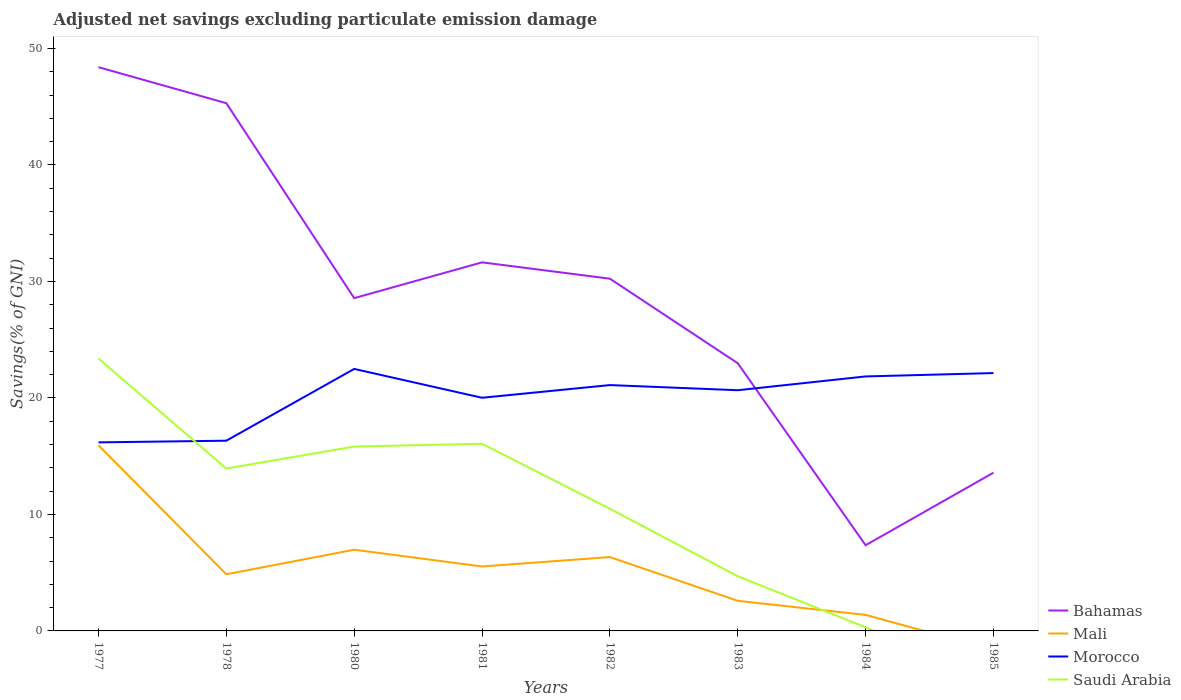How many different coloured lines are there?
Offer a terse response. 4. Across all years, what is the maximum adjusted net savings in Mali?
Ensure brevity in your answer.  0. What is the total adjusted net savings in Bahamas in the graph?
Offer a very short reply. 3.09. What is the difference between the highest and the second highest adjusted net savings in Mali?
Give a very brief answer. 15.94. Are the values on the major ticks of Y-axis written in scientific E-notation?
Your answer should be compact. No. Where does the legend appear in the graph?
Make the answer very short. Bottom right. How are the legend labels stacked?
Your answer should be very brief. Vertical. What is the title of the graph?
Offer a terse response. Adjusted net savings excluding particulate emission damage. Does "Latin America(developing only)" appear as one of the legend labels in the graph?
Give a very brief answer. No. What is the label or title of the Y-axis?
Ensure brevity in your answer.  Savings(% of GNI). What is the Savings(% of GNI) of Bahamas in 1977?
Provide a succinct answer. 48.4. What is the Savings(% of GNI) of Mali in 1977?
Give a very brief answer. 15.94. What is the Savings(% of GNI) of Morocco in 1977?
Ensure brevity in your answer.  16.19. What is the Savings(% of GNI) of Saudi Arabia in 1977?
Your response must be concise. 23.38. What is the Savings(% of GNI) in Bahamas in 1978?
Offer a very short reply. 45.31. What is the Savings(% of GNI) in Mali in 1978?
Make the answer very short. 4.86. What is the Savings(% of GNI) in Morocco in 1978?
Your answer should be very brief. 16.33. What is the Savings(% of GNI) in Saudi Arabia in 1978?
Provide a succinct answer. 13.94. What is the Savings(% of GNI) of Bahamas in 1980?
Offer a terse response. 28.57. What is the Savings(% of GNI) in Mali in 1980?
Offer a very short reply. 6.97. What is the Savings(% of GNI) in Morocco in 1980?
Keep it short and to the point. 22.49. What is the Savings(% of GNI) in Saudi Arabia in 1980?
Offer a terse response. 15.83. What is the Savings(% of GNI) of Bahamas in 1981?
Your answer should be compact. 31.64. What is the Savings(% of GNI) of Mali in 1981?
Keep it short and to the point. 5.53. What is the Savings(% of GNI) in Morocco in 1981?
Your answer should be compact. 20.02. What is the Savings(% of GNI) of Saudi Arabia in 1981?
Offer a very short reply. 16.07. What is the Savings(% of GNI) of Bahamas in 1982?
Offer a terse response. 30.24. What is the Savings(% of GNI) of Mali in 1982?
Give a very brief answer. 6.34. What is the Savings(% of GNI) in Morocco in 1982?
Your answer should be compact. 21.1. What is the Savings(% of GNI) in Saudi Arabia in 1982?
Provide a short and direct response. 10.49. What is the Savings(% of GNI) of Bahamas in 1983?
Provide a succinct answer. 22.98. What is the Savings(% of GNI) of Mali in 1983?
Your answer should be compact. 2.58. What is the Savings(% of GNI) in Morocco in 1983?
Keep it short and to the point. 20.66. What is the Savings(% of GNI) in Saudi Arabia in 1983?
Make the answer very short. 4.69. What is the Savings(% of GNI) of Bahamas in 1984?
Your answer should be compact. 7.36. What is the Savings(% of GNI) in Mali in 1984?
Give a very brief answer. 1.38. What is the Savings(% of GNI) of Morocco in 1984?
Ensure brevity in your answer.  21.85. What is the Savings(% of GNI) of Saudi Arabia in 1984?
Your response must be concise. 0.31. What is the Savings(% of GNI) of Bahamas in 1985?
Offer a terse response. 13.58. What is the Savings(% of GNI) of Morocco in 1985?
Give a very brief answer. 22.14. What is the Savings(% of GNI) of Saudi Arabia in 1985?
Offer a terse response. 0. Across all years, what is the maximum Savings(% of GNI) in Bahamas?
Keep it short and to the point. 48.4. Across all years, what is the maximum Savings(% of GNI) of Mali?
Give a very brief answer. 15.94. Across all years, what is the maximum Savings(% of GNI) in Morocco?
Keep it short and to the point. 22.49. Across all years, what is the maximum Savings(% of GNI) of Saudi Arabia?
Give a very brief answer. 23.38. Across all years, what is the minimum Savings(% of GNI) of Bahamas?
Provide a succinct answer. 7.36. Across all years, what is the minimum Savings(% of GNI) in Morocco?
Provide a short and direct response. 16.19. Across all years, what is the minimum Savings(% of GNI) of Saudi Arabia?
Ensure brevity in your answer.  0. What is the total Savings(% of GNI) in Bahamas in the graph?
Your answer should be very brief. 228.07. What is the total Savings(% of GNI) of Mali in the graph?
Make the answer very short. 43.61. What is the total Savings(% of GNI) of Morocco in the graph?
Your answer should be compact. 160.78. What is the total Savings(% of GNI) of Saudi Arabia in the graph?
Provide a succinct answer. 84.71. What is the difference between the Savings(% of GNI) in Bahamas in 1977 and that in 1978?
Your answer should be compact. 3.09. What is the difference between the Savings(% of GNI) in Mali in 1977 and that in 1978?
Keep it short and to the point. 11.07. What is the difference between the Savings(% of GNI) in Morocco in 1977 and that in 1978?
Offer a terse response. -0.14. What is the difference between the Savings(% of GNI) of Saudi Arabia in 1977 and that in 1978?
Your response must be concise. 9.44. What is the difference between the Savings(% of GNI) in Bahamas in 1977 and that in 1980?
Keep it short and to the point. 19.83. What is the difference between the Savings(% of GNI) in Mali in 1977 and that in 1980?
Your answer should be compact. 8.96. What is the difference between the Savings(% of GNI) in Morocco in 1977 and that in 1980?
Your answer should be compact. -6.3. What is the difference between the Savings(% of GNI) in Saudi Arabia in 1977 and that in 1980?
Give a very brief answer. 7.56. What is the difference between the Savings(% of GNI) of Bahamas in 1977 and that in 1981?
Your answer should be compact. 16.75. What is the difference between the Savings(% of GNI) in Mali in 1977 and that in 1981?
Your response must be concise. 10.41. What is the difference between the Savings(% of GNI) in Morocco in 1977 and that in 1981?
Give a very brief answer. -3.83. What is the difference between the Savings(% of GNI) of Saudi Arabia in 1977 and that in 1981?
Offer a terse response. 7.32. What is the difference between the Savings(% of GNI) in Bahamas in 1977 and that in 1982?
Offer a terse response. 18.16. What is the difference between the Savings(% of GNI) in Mali in 1977 and that in 1982?
Offer a very short reply. 9.6. What is the difference between the Savings(% of GNI) of Morocco in 1977 and that in 1982?
Give a very brief answer. -4.92. What is the difference between the Savings(% of GNI) in Saudi Arabia in 1977 and that in 1982?
Make the answer very short. 12.9. What is the difference between the Savings(% of GNI) in Bahamas in 1977 and that in 1983?
Offer a terse response. 25.42. What is the difference between the Savings(% of GNI) in Mali in 1977 and that in 1983?
Provide a short and direct response. 13.35. What is the difference between the Savings(% of GNI) in Morocco in 1977 and that in 1983?
Keep it short and to the point. -4.48. What is the difference between the Savings(% of GNI) in Saudi Arabia in 1977 and that in 1983?
Make the answer very short. 18.69. What is the difference between the Savings(% of GNI) of Bahamas in 1977 and that in 1984?
Keep it short and to the point. 41.04. What is the difference between the Savings(% of GNI) in Mali in 1977 and that in 1984?
Make the answer very short. 14.56. What is the difference between the Savings(% of GNI) in Morocco in 1977 and that in 1984?
Ensure brevity in your answer.  -5.66. What is the difference between the Savings(% of GNI) of Saudi Arabia in 1977 and that in 1984?
Offer a terse response. 23.08. What is the difference between the Savings(% of GNI) of Bahamas in 1977 and that in 1985?
Offer a very short reply. 34.81. What is the difference between the Savings(% of GNI) in Morocco in 1977 and that in 1985?
Give a very brief answer. -5.95. What is the difference between the Savings(% of GNI) in Bahamas in 1978 and that in 1980?
Give a very brief answer. 16.74. What is the difference between the Savings(% of GNI) of Mali in 1978 and that in 1980?
Your response must be concise. -2.11. What is the difference between the Savings(% of GNI) in Morocco in 1978 and that in 1980?
Offer a terse response. -6.16. What is the difference between the Savings(% of GNI) in Saudi Arabia in 1978 and that in 1980?
Offer a terse response. -1.89. What is the difference between the Savings(% of GNI) in Bahamas in 1978 and that in 1981?
Provide a short and direct response. 13.66. What is the difference between the Savings(% of GNI) of Mali in 1978 and that in 1981?
Your answer should be compact. -0.67. What is the difference between the Savings(% of GNI) in Morocco in 1978 and that in 1981?
Your answer should be compact. -3.69. What is the difference between the Savings(% of GNI) of Saudi Arabia in 1978 and that in 1981?
Make the answer very short. -2.13. What is the difference between the Savings(% of GNI) in Bahamas in 1978 and that in 1982?
Provide a short and direct response. 15.07. What is the difference between the Savings(% of GNI) in Mali in 1978 and that in 1982?
Give a very brief answer. -1.48. What is the difference between the Savings(% of GNI) in Morocco in 1978 and that in 1982?
Provide a succinct answer. -4.77. What is the difference between the Savings(% of GNI) of Saudi Arabia in 1978 and that in 1982?
Your response must be concise. 3.45. What is the difference between the Savings(% of GNI) of Bahamas in 1978 and that in 1983?
Provide a succinct answer. 22.33. What is the difference between the Savings(% of GNI) of Mali in 1978 and that in 1983?
Your response must be concise. 2.28. What is the difference between the Savings(% of GNI) of Morocco in 1978 and that in 1983?
Keep it short and to the point. -4.33. What is the difference between the Savings(% of GNI) of Saudi Arabia in 1978 and that in 1983?
Keep it short and to the point. 9.25. What is the difference between the Savings(% of GNI) of Bahamas in 1978 and that in 1984?
Your answer should be compact. 37.95. What is the difference between the Savings(% of GNI) in Mali in 1978 and that in 1984?
Provide a short and direct response. 3.48. What is the difference between the Savings(% of GNI) in Morocco in 1978 and that in 1984?
Your response must be concise. -5.52. What is the difference between the Savings(% of GNI) of Saudi Arabia in 1978 and that in 1984?
Your response must be concise. 13.63. What is the difference between the Savings(% of GNI) of Bahamas in 1978 and that in 1985?
Provide a short and direct response. 31.72. What is the difference between the Savings(% of GNI) of Morocco in 1978 and that in 1985?
Offer a terse response. -5.81. What is the difference between the Savings(% of GNI) of Bahamas in 1980 and that in 1981?
Provide a succinct answer. -3.07. What is the difference between the Savings(% of GNI) in Mali in 1980 and that in 1981?
Your answer should be compact. 1.44. What is the difference between the Savings(% of GNI) of Morocco in 1980 and that in 1981?
Make the answer very short. 2.48. What is the difference between the Savings(% of GNI) in Saudi Arabia in 1980 and that in 1981?
Your response must be concise. -0.24. What is the difference between the Savings(% of GNI) of Bahamas in 1980 and that in 1982?
Ensure brevity in your answer.  -1.67. What is the difference between the Savings(% of GNI) in Mali in 1980 and that in 1982?
Give a very brief answer. 0.63. What is the difference between the Savings(% of GNI) of Morocco in 1980 and that in 1982?
Your answer should be compact. 1.39. What is the difference between the Savings(% of GNI) in Saudi Arabia in 1980 and that in 1982?
Provide a succinct answer. 5.34. What is the difference between the Savings(% of GNI) in Bahamas in 1980 and that in 1983?
Provide a short and direct response. 5.59. What is the difference between the Savings(% of GNI) of Mali in 1980 and that in 1983?
Provide a succinct answer. 4.39. What is the difference between the Savings(% of GNI) in Morocco in 1980 and that in 1983?
Offer a very short reply. 1.83. What is the difference between the Savings(% of GNI) of Saudi Arabia in 1980 and that in 1983?
Your response must be concise. 11.14. What is the difference between the Savings(% of GNI) in Bahamas in 1980 and that in 1984?
Ensure brevity in your answer.  21.21. What is the difference between the Savings(% of GNI) of Mali in 1980 and that in 1984?
Keep it short and to the point. 5.59. What is the difference between the Savings(% of GNI) in Morocco in 1980 and that in 1984?
Ensure brevity in your answer.  0.65. What is the difference between the Savings(% of GNI) in Saudi Arabia in 1980 and that in 1984?
Offer a terse response. 15.52. What is the difference between the Savings(% of GNI) of Bahamas in 1980 and that in 1985?
Make the answer very short. 14.99. What is the difference between the Savings(% of GNI) in Morocco in 1980 and that in 1985?
Provide a succinct answer. 0.36. What is the difference between the Savings(% of GNI) of Bahamas in 1981 and that in 1982?
Provide a short and direct response. 1.4. What is the difference between the Savings(% of GNI) of Mali in 1981 and that in 1982?
Make the answer very short. -0.81. What is the difference between the Savings(% of GNI) of Morocco in 1981 and that in 1982?
Your answer should be very brief. -1.09. What is the difference between the Savings(% of GNI) of Saudi Arabia in 1981 and that in 1982?
Make the answer very short. 5.58. What is the difference between the Savings(% of GNI) of Bahamas in 1981 and that in 1983?
Keep it short and to the point. 8.66. What is the difference between the Savings(% of GNI) in Mali in 1981 and that in 1983?
Your answer should be very brief. 2.95. What is the difference between the Savings(% of GNI) in Morocco in 1981 and that in 1983?
Give a very brief answer. -0.65. What is the difference between the Savings(% of GNI) in Saudi Arabia in 1981 and that in 1983?
Provide a short and direct response. 11.38. What is the difference between the Savings(% of GNI) in Bahamas in 1981 and that in 1984?
Your answer should be very brief. 24.28. What is the difference between the Savings(% of GNI) in Mali in 1981 and that in 1984?
Your response must be concise. 4.15. What is the difference between the Savings(% of GNI) of Morocco in 1981 and that in 1984?
Keep it short and to the point. -1.83. What is the difference between the Savings(% of GNI) in Saudi Arabia in 1981 and that in 1984?
Make the answer very short. 15.76. What is the difference between the Savings(% of GNI) of Bahamas in 1981 and that in 1985?
Give a very brief answer. 18.06. What is the difference between the Savings(% of GNI) of Morocco in 1981 and that in 1985?
Make the answer very short. -2.12. What is the difference between the Savings(% of GNI) in Bahamas in 1982 and that in 1983?
Your answer should be compact. 7.26. What is the difference between the Savings(% of GNI) of Mali in 1982 and that in 1983?
Ensure brevity in your answer.  3.76. What is the difference between the Savings(% of GNI) of Morocco in 1982 and that in 1983?
Make the answer very short. 0.44. What is the difference between the Savings(% of GNI) in Saudi Arabia in 1982 and that in 1983?
Your answer should be compact. 5.8. What is the difference between the Savings(% of GNI) in Bahamas in 1982 and that in 1984?
Your answer should be very brief. 22.88. What is the difference between the Savings(% of GNI) in Mali in 1982 and that in 1984?
Make the answer very short. 4.96. What is the difference between the Savings(% of GNI) in Morocco in 1982 and that in 1984?
Provide a short and direct response. -0.74. What is the difference between the Savings(% of GNI) in Saudi Arabia in 1982 and that in 1984?
Provide a short and direct response. 10.18. What is the difference between the Savings(% of GNI) of Bahamas in 1982 and that in 1985?
Your answer should be very brief. 16.66. What is the difference between the Savings(% of GNI) in Morocco in 1982 and that in 1985?
Provide a succinct answer. -1.03. What is the difference between the Savings(% of GNI) of Bahamas in 1983 and that in 1984?
Give a very brief answer. 15.62. What is the difference between the Savings(% of GNI) of Mali in 1983 and that in 1984?
Your answer should be very brief. 1.21. What is the difference between the Savings(% of GNI) of Morocco in 1983 and that in 1984?
Make the answer very short. -1.18. What is the difference between the Savings(% of GNI) of Saudi Arabia in 1983 and that in 1984?
Make the answer very short. 4.38. What is the difference between the Savings(% of GNI) in Bahamas in 1983 and that in 1985?
Provide a succinct answer. 9.4. What is the difference between the Savings(% of GNI) of Morocco in 1983 and that in 1985?
Offer a very short reply. -1.47. What is the difference between the Savings(% of GNI) of Bahamas in 1984 and that in 1985?
Your answer should be compact. -6.23. What is the difference between the Savings(% of GNI) in Morocco in 1984 and that in 1985?
Your response must be concise. -0.29. What is the difference between the Savings(% of GNI) in Bahamas in 1977 and the Savings(% of GNI) in Mali in 1978?
Give a very brief answer. 43.53. What is the difference between the Savings(% of GNI) of Bahamas in 1977 and the Savings(% of GNI) of Morocco in 1978?
Your answer should be very brief. 32.07. What is the difference between the Savings(% of GNI) in Bahamas in 1977 and the Savings(% of GNI) in Saudi Arabia in 1978?
Make the answer very short. 34.46. What is the difference between the Savings(% of GNI) in Mali in 1977 and the Savings(% of GNI) in Morocco in 1978?
Make the answer very short. -0.39. What is the difference between the Savings(% of GNI) of Mali in 1977 and the Savings(% of GNI) of Saudi Arabia in 1978?
Offer a very short reply. 2. What is the difference between the Savings(% of GNI) of Morocco in 1977 and the Savings(% of GNI) of Saudi Arabia in 1978?
Provide a short and direct response. 2.25. What is the difference between the Savings(% of GNI) in Bahamas in 1977 and the Savings(% of GNI) in Mali in 1980?
Provide a short and direct response. 41.42. What is the difference between the Savings(% of GNI) in Bahamas in 1977 and the Savings(% of GNI) in Morocco in 1980?
Ensure brevity in your answer.  25.9. What is the difference between the Savings(% of GNI) of Bahamas in 1977 and the Savings(% of GNI) of Saudi Arabia in 1980?
Give a very brief answer. 32.57. What is the difference between the Savings(% of GNI) of Mali in 1977 and the Savings(% of GNI) of Morocco in 1980?
Your answer should be very brief. -6.56. What is the difference between the Savings(% of GNI) in Mali in 1977 and the Savings(% of GNI) in Saudi Arabia in 1980?
Offer a terse response. 0.11. What is the difference between the Savings(% of GNI) in Morocco in 1977 and the Savings(% of GNI) in Saudi Arabia in 1980?
Provide a short and direct response. 0.36. What is the difference between the Savings(% of GNI) in Bahamas in 1977 and the Savings(% of GNI) in Mali in 1981?
Ensure brevity in your answer.  42.86. What is the difference between the Savings(% of GNI) in Bahamas in 1977 and the Savings(% of GNI) in Morocco in 1981?
Ensure brevity in your answer.  28.38. What is the difference between the Savings(% of GNI) in Bahamas in 1977 and the Savings(% of GNI) in Saudi Arabia in 1981?
Offer a very short reply. 32.33. What is the difference between the Savings(% of GNI) in Mali in 1977 and the Savings(% of GNI) in Morocco in 1981?
Offer a terse response. -4.08. What is the difference between the Savings(% of GNI) of Mali in 1977 and the Savings(% of GNI) of Saudi Arabia in 1981?
Make the answer very short. -0.13. What is the difference between the Savings(% of GNI) in Morocco in 1977 and the Savings(% of GNI) in Saudi Arabia in 1981?
Offer a terse response. 0.12. What is the difference between the Savings(% of GNI) of Bahamas in 1977 and the Savings(% of GNI) of Mali in 1982?
Your answer should be compact. 42.06. What is the difference between the Savings(% of GNI) in Bahamas in 1977 and the Savings(% of GNI) in Morocco in 1982?
Make the answer very short. 27.29. What is the difference between the Savings(% of GNI) in Bahamas in 1977 and the Savings(% of GNI) in Saudi Arabia in 1982?
Offer a terse response. 37.91. What is the difference between the Savings(% of GNI) in Mali in 1977 and the Savings(% of GNI) in Morocco in 1982?
Offer a very short reply. -5.17. What is the difference between the Savings(% of GNI) of Mali in 1977 and the Savings(% of GNI) of Saudi Arabia in 1982?
Your answer should be very brief. 5.45. What is the difference between the Savings(% of GNI) of Morocco in 1977 and the Savings(% of GNI) of Saudi Arabia in 1982?
Give a very brief answer. 5.7. What is the difference between the Savings(% of GNI) in Bahamas in 1977 and the Savings(% of GNI) in Mali in 1983?
Ensure brevity in your answer.  45.81. What is the difference between the Savings(% of GNI) of Bahamas in 1977 and the Savings(% of GNI) of Morocco in 1983?
Your response must be concise. 27.73. What is the difference between the Savings(% of GNI) in Bahamas in 1977 and the Savings(% of GNI) in Saudi Arabia in 1983?
Offer a terse response. 43.7. What is the difference between the Savings(% of GNI) in Mali in 1977 and the Savings(% of GNI) in Morocco in 1983?
Your answer should be compact. -4.73. What is the difference between the Savings(% of GNI) of Mali in 1977 and the Savings(% of GNI) of Saudi Arabia in 1983?
Your answer should be compact. 11.25. What is the difference between the Savings(% of GNI) of Morocco in 1977 and the Savings(% of GNI) of Saudi Arabia in 1983?
Offer a very short reply. 11.5. What is the difference between the Savings(% of GNI) in Bahamas in 1977 and the Savings(% of GNI) in Mali in 1984?
Provide a short and direct response. 47.02. What is the difference between the Savings(% of GNI) of Bahamas in 1977 and the Savings(% of GNI) of Morocco in 1984?
Your answer should be compact. 26.55. What is the difference between the Savings(% of GNI) in Bahamas in 1977 and the Savings(% of GNI) in Saudi Arabia in 1984?
Offer a terse response. 48.09. What is the difference between the Savings(% of GNI) in Mali in 1977 and the Savings(% of GNI) in Morocco in 1984?
Your answer should be very brief. -5.91. What is the difference between the Savings(% of GNI) of Mali in 1977 and the Savings(% of GNI) of Saudi Arabia in 1984?
Your answer should be very brief. 15.63. What is the difference between the Savings(% of GNI) of Morocco in 1977 and the Savings(% of GNI) of Saudi Arabia in 1984?
Your answer should be compact. 15.88. What is the difference between the Savings(% of GNI) of Bahamas in 1977 and the Savings(% of GNI) of Morocco in 1985?
Offer a very short reply. 26.26. What is the difference between the Savings(% of GNI) in Mali in 1977 and the Savings(% of GNI) in Morocco in 1985?
Ensure brevity in your answer.  -6.2. What is the difference between the Savings(% of GNI) of Bahamas in 1978 and the Savings(% of GNI) of Mali in 1980?
Keep it short and to the point. 38.33. What is the difference between the Savings(% of GNI) in Bahamas in 1978 and the Savings(% of GNI) in Morocco in 1980?
Provide a short and direct response. 22.81. What is the difference between the Savings(% of GNI) of Bahamas in 1978 and the Savings(% of GNI) of Saudi Arabia in 1980?
Offer a very short reply. 29.48. What is the difference between the Savings(% of GNI) in Mali in 1978 and the Savings(% of GNI) in Morocco in 1980?
Make the answer very short. -17.63. What is the difference between the Savings(% of GNI) in Mali in 1978 and the Savings(% of GNI) in Saudi Arabia in 1980?
Give a very brief answer. -10.97. What is the difference between the Savings(% of GNI) of Morocco in 1978 and the Savings(% of GNI) of Saudi Arabia in 1980?
Give a very brief answer. 0.5. What is the difference between the Savings(% of GNI) in Bahamas in 1978 and the Savings(% of GNI) in Mali in 1981?
Make the answer very short. 39.77. What is the difference between the Savings(% of GNI) in Bahamas in 1978 and the Savings(% of GNI) in Morocco in 1981?
Your answer should be compact. 25.29. What is the difference between the Savings(% of GNI) of Bahamas in 1978 and the Savings(% of GNI) of Saudi Arabia in 1981?
Keep it short and to the point. 29.24. What is the difference between the Savings(% of GNI) of Mali in 1978 and the Savings(% of GNI) of Morocco in 1981?
Ensure brevity in your answer.  -15.15. What is the difference between the Savings(% of GNI) in Mali in 1978 and the Savings(% of GNI) in Saudi Arabia in 1981?
Ensure brevity in your answer.  -11.21. What is the difference between the Savings(% of GNI) in Morocco in 1978 and the Savings(% of GNI) in Saudi Arabia in 1981?
Provide a succinct answer. 0.26. What is the difference between the Savings(% of GNI) of Bahamas in 1978 and the Savings(% of GNI) of Mali in 1982?
Offer a very short reply. 38.96. What is the difference between the Savings(% of GNI) in Bahamas in 1978 and the Savings(% of GNI) in Morocco in 1982?
Your response must be concise. 24.2. What is the difference between the Savings(% of GNI) in Bahamas in 1978 and the Savings(% of GNI) in Saudi Arabia in 1982?
Your response must be concise. 34.82. What is the difference between the Savings(% of GNI) of Mali in 1978 and the Savings(% of GNI) of Morocco in 1982?
Offer a very short reply. -16.24. What is the difference between the Savings(% of GNI) in Mali in 1978 and the Savings(% of GNI) in Saudi Arabia in 1982?
Offer a terse response. -5.62. What is the difference between the Savings(% of GNI) in Morocco in 1978 and the Savings(% of GNI) in Saudi Arabia in 1982?
Make the answer very short. 5.84. What is the difference between the Savings(% of GNI) of Bahamas in 1978 and the Savings(% of GNI) of Mali in 1983?
Give a very brief answer. 42.72. What is the difference between the Savings(% of GNI) of Bahamas in 1978 and the Savings(% of GNI) of Morocco in 1983?
Offer a terse response. 24.64. What is the difference between the Savings(% of GNI) in Bahamas in 1978 and the Savings(% of GNI) in Saudi Arabia in 1983?
Offer a very short reply. 40.61. What is the difference between the Savings(% of GNI) of Mali in 1978 and the Savings(% of GNI) of Morocco in 1983?
Provide a short and direct response. -15.8. What is the difference between the Savings(% of GNI) of Mali in 1978 and the Savings(% of GNI) of Saudi Arabia in 1983?
Your answer should be compact. 0.17. What is the difference between the Savings(% of GNI) of Morocco in 1978 and the Savings(% of GNI) of Saudi Arabia in 1983?
Ensure brevity in your answer.  11.64. What is the difference between the Savings(% of GNI) in Bahamas in 1978 and the Savings(% of GNI) in Mali in 1984?
Offer a terse response. 43.93. What is the difference between the Savings(% of GNI) of Bahamas in 1978 and the Savings(% of GNI) of Morocco in 1984?
Ensure brevity in your answer.  23.46. What is the difference between the Savings(% of GNI) in Bahamas in 1978 and the Savings(% of GNI) in Saudi Arabia in 1984?
Ensure brevity in your answer.  45. What is the difference between the Savings(% of GNI) in Mali in 1978 and the Savings(% of GNI) in Morocco in 1984?
Provide a short and direct response. -16.98. What is the difference between the Savings(% of GNI) of Mali in 1978 and the Savings(% of GNI) of Saudi Arabia in 1984?
Provide a short and direct response. 4.55. What is the difference between the Savings(% of GNI) in Morocco in 1978 and the Savings(% of GNI) in Saudi Arabia in 1984?
Make the answer very short. 16.02. What is the difference between the Savings(% of GNI) in Bahamas in 1978 and the Savings(% of GNI) in Morocco in 1985?
Your response must be concise. 23.17. What is the difference between the Savings(% of GNI) in Mali in 1978 and the Savings(% of GNI) in Morocco in 1985?
Offer a very short reply. -17.27. What is the difference between the Savings(% of GNI) in Bahamas in 1980 and the Savings(% of GNI) in Mali in 1981?
Give a very brief answer. 23.04. What is the difference between the Savings(% of GNI) of Bahamas in 1980 and the Savings(% of GNI) of Morocco in 1981?
Make the answer very short. 8.55. What is the difference between the Savings(% of GNI) in Bahamas in 1980 and the Savings(% of GNI) in Saudi Arabia in 1981?
Offer a terse response. 12.5. What is the difference between the Savings(% of GNI) of Mali in 1980 and the Savings(% of GNI) of Morocco in 1981?
Provide a short and direct response. -13.04. What is the difference between the Savings(% of GNI) in Mali in 1980 and the Savings(% of GNI) in Saudi Arabia in 1981?
Provide a succinct answer. -9.1. What is the difference between the Savings(% of GNI) of Morocco in 1980 and the Savings(% of GNI) of Saudi Arabia in 1981?
Provide a short and direct response. 6.42. What is the difference between the Savings(% of GNI) in Bahamas in 1980 and the Savings(% of GNI) in Mali in 1982?
Offer a terse response. 22.23. What is the difference between the Savings(% of GNI) in Bahamas in 1980 and the Savings(% of GNI) in Morocco in 1982?
Provide a short and direct response. 7.46. What is the difference between the Savings(% of GNI) of Bahamas in 1980 and the Savings(% of GNI) of Saudi Arabia in 1982?
Provide a succinct answer. 18.08. What is the difference between the Savings(% of GNI) in Mali in 1980 and the Savings(% of GNI) in Morocco in 1982?
Give a very brief answer. -14.13. What is the difference between the Savings(% of GNI) in Mali in 1980 and the Savings(% of GNI) in Saudi Arabia in 1982?
Give a very brief answer. -3.51. What is the difference between the Savings(% of GNI) in Morocco in 1980 and the Savings(% of GNI) in Saudi Arabia in 1982?
Provide a short and direct response. 12.01. What is the difference between the Savings(% of GNI) of Bahamas in 1980 and the Savings(% of GNI) of Mali in 1983?
Provide a succinct answer. 25.98. What is the difference between the Savings(% of GNI) in Bahamas in 1980 and the Savings(% of GNI) in Morocco in 1983?
Ensure brevity in your answer.  7.91. What is the difference between the Savings(% of GNI) of Bahamas in 1980 and the Savings(% of GNI) of Saudi Arabia in 1983?
Your answer should be very brief. 23.88. What is the difference between the Savings(% of GNI) of Mali in 1980 and the Savings(% of GNI) of Morocco in 1983?
Ensure brevity in your answer.  -13.69. What is the difference between the Savings(% of GNI) of Mali in 1980 and the Savings(% of GNI) of Saudi Arabia in 1983?
Keep it short and to the point. 2.28. What is the difference between the Savings(% of GNI) of Morocco in 1980 and the Savings(% of GNI) of Saudi Arabia in 1983?
Give a very brief answer. 17.8. What is the difference between the Savings(% of GNI) in Bahamas in 1980 and the Savings(% of GNI) in Mali in 1984?
Your response must be concise. 27.19. What is the difference between the Savings(% of GNI) in Bahamas in 1980 and the Savings(% of GNI) in Morocco in 1984?
Provide a succinct answer. 6.72. What is the difference between the Savings(% of GNI) of Bahamas in 1980 and the Savings(% of GNI) of Saudi Arabia in 1984?
Your answer should be very brief. 28.26. What is the difference between the Savings(% of GNI) of Mali in 1980 and the Savings(% of GNI) of Morocco in 1984?
Make the answer very short. -14.87. What is the difference between the Savings(% of GNI) of Mali in 1980 and the Savings(% of GNI) of Saudi Arabia in 1984?
Keep it short and to the point. 6.66. What is the difference between the Savings(% of GNI) in Morocco in 1980 and the Savings(% of GNI) in Saudi Arabia in 1984?
Your response must be concise. 22.19. What is the difference between the Savings(% of GNI) in Bahamas in 1980 and the Savings(% of GNI) in Morocco in 1985?
Offer a very short reply. 6.43. What is the difference between the Savings(% of GNI) of Mali in 1980 and the Savings(% of GNI) of Morocco in 1985?
Offer a terse response. -15.16. What is the difference between the Savings(% of GNI) in Bahamas in 1981 and the Savings(% of GNI) in Mali in 1982?
Your response must be concise. 25.3. What is the difference between the Savings(% of GNI) in Bahamas in 1981 and the Savings(% of GNI) in Morocco in 1982?
Ensure brevity in your answer.  10.54. What is the difference between the Savings(% of GNI) of Bahamas in 1981 and the Savings(% of GNI) of Saudi Arabia in 1982?
Offer a terse response. 21.15. What is the difference between the Savings(% of GNI) in Mali in 1981 and the Savings(% of GNI) in Morocco in 1982?
Your response must be concise. -15.57. What is the difference between the Savings(% of GNI) in Mali in 1981 and the Savings(% of GNI) in Saudi Arabia in 1982?
Your answer should be very brief. -4.95. What is the difference between the Savings(% of GNI) of Morocco in 1981 and the Savings(% of GNI) of Saudi Arabia in 1982?
Your answer should be very brief. 9.53. What is the difference between the Savings(% of GNI) in Bahamas in 1981 and the Savings(% of GNI) in Mali in 1983?
Provide a short and direct response. 29.06. What is the difference between the Savings(% of GNI) in Bahamas in 1981 and the Savings(% of GNI) in Morocco in 1983?
Provide a short and direct response. 10.98. What is the difference between the Savings(% of GNI) of Bahamas in 1981 and the Savings(% of GNI) of Saudi Arabia in 1983?
Give a very brief answer. 26.95. What is the difference between the Savings(% of GNI) of Mali in 1981 and the Savings(% of GNI) of Morocco in 1983?
Provide a succinct answer. -15.13. What is the difference between the Savings(% of GNI) in Mali in 1981 and the Savings(% of GNI) in Saudi Arabia in 1983?
Your response must be concise. 0.84. What is the difference between the Savings(% of GNI) of Morocco in 1981 and the Savings(% of GNI) of Saudi Arabia in 1983?
Ensure brevity in your answer.  15.33. What is the difference between the Savings(% of GNI) of Bahamas in 1981 and the Savings(% of GNI) of Mali in 1984?
Give a very brief answer. 30.26. What is the difference between the Savings(% of GNI) of Bahamas in 1981 and the Savings(% of GNI) of Morocco in 1984?
Your answer should be very brief. 9.79. What is the difference between the Savings(% of GNI) in Bahamas in 1981 and the Savings(% of GNI) in Saudi Arabia in 1984?
Make the answer very short. 31.33. What is the difference between the Savings(% of GNI) in Mali in 1981 and the Savings(% of GNI) in Morocco in 1984?
Make the answer very short. -16.32. What is the difference between the Savings(% of GNI) of Mali in 1981 and the Savings(% of GNI) of Saudi Arabia in 1984?
Keep it short and to the point. 5.22. What is the difference between the Savings(% of GNI) of Morocco in 1981 and the Savings(% of GNI) of Saudi Arabia in 1984?
Offer a very short reply. 19.71. What is the difference between the Savings(% of GNI) of Bahamas in 1981 and the Savings(% of GNI) of Morocco in 1985?
Offer a terse response. 9.5. What is the difference between the Savings(% of GNI) of Mali in 1981 and the Savings(% of GNI) of Morocco in 1985?
Provide a short and direct response. -16.6. What is the difference between the Savings(% of GNI) in Bahamas in 1982 and the Savings(% of GNI) in Mali in 1983?
Ensure brevity in your answer.  27.65. What is the difference between the Savings(% of GNI) in Bahamas in 1982 and the Savings(% of GNI) in Morocco in 1983?
Give a very brief answer. 9.58. What is the difference between the Savings(% of GNI) in Bahamas in 1982 and the Savings(% of GNI) in Saudi Arabia in 1983?
Keep it short and to the point. 25.55. What is the difference between the Savings(% of GNI) of Mali in 1982 and the Savings(% of GNI) of Morocco in 1983?
Your response must be concise. -14.32. What is the difference between the Savings(% of GNI) of Mali in 1982 and the Savings(% of GNI) of Saudi Arabia in 1983?
Provide a short and direct response. 1.65. What is the difference between the Savings(% of GNI) of Morocco in 1982 and the Savings(% of GNI) of Saudi Arabia in 1983?
Your answer should be very brief. 16.41. What is the difference between the Savings(% of GNI) in Bahamas in 1982 and the Savings(% of GNI) in Mali in 1984?
Provide a succinct answer. 28.86. What is the difference between the Savings(% of GNI) in Bahamas in 1982 and the Savings(% of GNI) in Morocco in 1984?
Give a very brief answer. 8.39. What is the difference between the Savings(% of GNI) of Bahamas in 1982 and the Savings(% of GNI) of Saudi Arabia in 1984?
Make the answer very short. 29.93. What is the difference between the Savings(% of GNI) in Mali in 1982 and the Savings(% of GNI) in Morocco in 1984?
Give a very brief answer. -15.51. What is the difference between the Savings(% of GNI) in Mali in 1982 and the Savings(% of GNI) in Saudi Arabia in 1984?
Your response must be concise. 6.03. What is the difference between the Savings(% of GNI) of Morocco in 1982 and the Savings(% of GNI) of Saudi Arabia in 1984?
Your answer should be compact. 20.8. What is the difference between the Savings(% of GNI) of Bahamas in 1982 and the Savings(% of GNI) of Morocco in 1985?
Keep it short and to the point. 8.1. What is the difference between the Savings(% of GNI) in Mali in 1982 and the Savings(% of GNI) in Morocco in 1985?
Give a very brief answer. -15.8. What is the difference between the Savings(% of GNI) of Bahamas in 1983 and the Savings(% of GNI) of Mali in 1984?
Offer a very short reply. 21.6. What is the difference between the Savings(% of GNI) of Bahamas in 1983 and the Savings(% of GNI) of Morocco in 1984?
Make the answer very short. 1.13. What is the difference between the Savings(% of GNI) in Bahamas in 1983 and the Savings(% of GNI) in Saudi Arabia in 1984?
Offer a very short reply. 22.67. What is the difference between the Savings(% of GNI) in Mali in 1983 and the Savings(% of GNI) in Morocco in 1984?
Your answer should be compact. -19.26. What is the difference between the Savings(% of GNI) of Mali in 1983 and the Savings(% of GNI) of Saudi Arabia in 1984?
Give a very brief answer. 2.28. What is the difference between the Savings(% of GNI) in Morocco in 1983 and the Savings(% of GNI) in Saudi Arabia in 1984?
Ensure brevity in your answer.  20.36. What is the difference between the Savings(% of GNI) in Bahamas in 1983 and the Savings(% of GNI) in Morocco in 1985?
Keep it short and to the point. 0.84. What is the difference between the Savings(% of GNI) of Mali in 1983 and the Savings(% of GNI) of Morocco in 1985?
Provide a short and direct response. -19.55. What is the difference between the Savings(% of GNI) of Bahamas in 1984 and the Savings(% of GNI) of Morocco in 1985?
Your response must be concise. -14.78. What is the difference between the Savings(% of GNI) in Mali in 1984 and the Savings(% of GNI) in Morocco in 1985?
Your answer should be very brief. -20.76. What is the average Savings(% of GNI) in Bahamas per year?
Offer a very short reply. 28.51. What is the average Savings(% of GNI) of Mali per year?
Give a very brief answer. 5.45. What is the average Savings(% of GNI) of Morocco per year?
Offer a very short reply. 20.1. What is the average Savings(% of GNI) of Saudi Arabia per year?
Give a very brief answer. 10.59. In the year 1977, what is the difference between the Savings(% of GNI) in Bahamas and Savings(% of GNI) in Mali?
Ensure brevity in your answer.  32.46. In the year 1977, what is the difference between the Savings(% of GNI) of Bahamas and Savings(% of GNI) of Morocco?
Your response must be concise. 32.21. In the year 1977, what is the difference between the Savings(% of GNI) in Bahamas and Savings(% of GNI) in Saudi Arabia?
Ensure brevity in your answer.  25.01. In the year 1977, what is the difference between the Savings(% of GNI) of Mali and Savings(% of GNI) of Morocco?
Make the answer very short. -0.25. In the year 1977, what is the difference between the Savings(% of GNI) in Mali and Savings(% of GNI) in Saudi Arabia?
Your answer should be compact. -7.45. In the year 1977, what is the difference between the Savings(% of GNI) in Morocco and Savings(% of GNI) in Saudi Arabia?
Offer a terse response. -7.2. In the year 1978, what is the difference between the Savings(% of GNI) of Bahamas and Savings(% of GNI) of Mali?
Provide a short and direct response. 40.44. In the year 1978, what is the difference between the Savings(% of GNI) in Bahamas and Savings(% of GNI) in Morocco?
Keep it short and to the point. 28.97. In the year 1978, what is the difference between the Savings(% of GNI) in Bahamas and Savings(% of GNI) in Saudi Arabia?
Offer a very short reply. 31.36. In the year 1978, what is the difference between the Savings(% of GNI) of Mali and Savings(% of GNI) of Morocco?
Provide a succinct answer. -11.47. In the year 1978, what is the difference between the Savings(% of GNI) of Mali and Savings(% of GNI) of Saudi Arabia?
Your response must be concise. -9.08. In the year 1978, what is the difference between the Savings(% of GNI) in Morocco and Savings(% of GNI) in Saudi Arabia?
Your answer should be very brief. 2.39. In the year 1980, what is the difference between the Savings(% of GNI) of Bahamas and Savings(% of GNI) of Mali?
Give a very brief answer. 21.6. In the year 1980, what is the difference between the Savings(% of GNI) of Bahamas and Savings(% of GNI) of Morocco?
Your answer should be compact. 6.08. In the year 1980, what is the difference between the Savings(% of GNI) in Bahamas and Savings(% of GNI) in Saudi Arabia?
Provide a succinct answer. 12.74. In the year 1980, what is the difference between the Savings(% of GNI) of Mali and Savings(% of GNI) of Morocco?
Offer a terse response. -15.52. In the year 1980, what is the difference between the Savings(% of GNI) of Mali and Savings(% of GNI) of Saudi Arabia?
Your answer should be very brief. -8.86. In the year 1980, what is the difference between the Savings(% of GNI) of Morocco and Savings(% of GNI) of Saudi Arabia?
Give a very brief answer. 6.66. In the year 1981, what is the difference between the Savings(% of GNI) of Bahamas and Savings(% of GNI) of Mali?
Make the answer very short. 26.11. In the year 1981, what is the difference between the Savings(% of GNI) of Bahamas and Savings(% of GNI) of Morocco?
Make the answer very short. 11.62. In the year 1981, what is the difference between the Savings(% of GNI) in Bahamas and Savings(% of GNI) in Saudi Arabia?
Make the answer very short. 15.57. In the year 1981, what is the difference between the Savings(% of GNI) of Mali and Savings(% of GNI) of Morocco?
Offer a terse response. -14.48. In the year 1981, what is the difference between the Savings(% of GNI) of Mali and Savings(% of GNI) of Saudi Arabia?
Your answer should be very brief. -10.54. In the year 1981, what is the difference between the Savings(% of GNI) in Morocco and Savings(% of GNI) in Saudi Arabia?
Give a very brief answer. 3.95. In the year 1982, what is the difference between the Savings(% of GNI) of Bahamas and Savings(% of GNI) of Mali?
Keep it short and to the point. 23.9. In the year 1982, what is the difference between the Savings(% of GNI) in Bahamas and Savings(% of GNI) in Morocco?
Keep it short and to the point. 9.13. In the year 1982, what is the difference between the Savings(% of GNI) of Bahamas and Savings(% of GNI) of Saudi Arabia?
Give a very brief answer. 19.75. In the year 1982, what is the difference between the Savings(% of GNI) in Mali and Savings(% of GNI) in Morocco?
Give a very brief answer. -14.76. In the year 1982, what is the difference between the Savings(% of GNI) in Mali and Savings(% of GNI) in Saudi Arabia?
Offer a terse response. -4.15. In the year 1982, what is the difference between the Savings(% of GNI) of Morocco and Savings(% of GNI) of Saudi Arabia?
Keep it short and to the point. 10.62. In the year 1983, what is the difference between the Savings(% of GNI) of Bahamas and Savings(% of GNI) of Mali?
Your answer should be compact. 20.39. In the year 1983, what is the difference between the Savings(% of GNI) of Bahamas and Savings(% of GNI) of Morocco?
Provide a succinct answer. 2.32. In the year 1983, what is the difference between the Savings(% of GNI) of Bahamas and Savings(% of GNI) of Saudi Arabia?
Your answer should be compact. 18.29. In the year 1983, what is the difference between the Savings(% of GNI) of Mali and Savings(% of GNI) of Morocco?
Your answer should be very brief. -18.08. In the year 1983, what is the difference between the Savings(% of GNI) in Mali and Savings(% of GNI) in Saudi Arabia?
Your answer should be compact. -2.11. In the year 1983, what is the difference between the Savings(% of GNI) in Morocco and Savings(% of GNI) in Saudi Arabia?
Your answer should be compact. 15.97. In the year 1984, what is the difference between the Savings(% of GNI) of Bahamas and Savings(% of GNI) of Mali?
Offer a very short reply. 5.98. In the year 1984, what is the difference between the Savings(% of GNI) in Bahamas and Savings(% of GNI) in Morocco?
Offer a terse response. -14.49. In the year 1984, what is the difference between the Savings(% of GNI) in Bahamas and Savings(% of GNI) in Saudi Arabia?
Make the answer very short. 7.05. In the year 1984, what is the difference between the Savings(% of GNI) of Mali and Savings(% of GNI) of Morocco?
Make the answer very short. -20.47. In the year 1984, what is the difference between the Savings(% of GNI) of Mali and Savings(% of GNI) of Saudi Arabia?
Your answer should be compact. 1.07. In the year 1984, what is the difference between the Savings(% of GNI) in Morocco and Savings(% of GNI) in Saudi Arabia?
Your response must be concise. 21.54. In the year 1985, what is the difference between the Savings(% of GNI) of Bahamas and Savings(% of GNI) of Morocco?
Provide a short and direct response. -8.55. What is the ratio of the Savings(% of GNI) in Bahamas in 1977 to that in 1978?
Provide a succinct answer. 1.07. What is the ratio of the Savings(% of GNI) of Mali in 1977 to that in 1978?
Your response must be concise. 3.28. What is the ratio of the Savings(% of GNI) in Saudi Arabia in 1977 to that in 1978?
Provide a short and direct response. 1.68. What is the ratio of the Savings(% of GNI) of Bahamas in 1977 to that in 1980?
Provide a short and direct response. 1.69. What is the ratio of the Savings(% of GNI) in Mali in 1977 to that in 1980?
Ensure brevity in your answer.  2.29. What is the ratio of the Savings(% of GNI) in Morocco in 1977 to that in 1980?
Your response must be concise. 0.72. What is the ratio of the Savings(% of GNI) of Saudi Arabia in 1977 to that in 1980?
Make the answer very short. 1.48. What is the ratio of the Savings(% of GNI) in Bahamas in 1977 to that in 1981?
Your answer should be very brief. 1.53. What is the ratio of the Savings(% of GNI) in Mali in 1977 to that in 1981?
Provide a short and direct response. 2.88. What is the ratio of the Savings(% of GNI) of Morocco in 1977 to that in 1981?
Provide a short and direct response. 0.81. What is the ratio of the Savings(% of GNI) in Saudi Arabia in 1977 to that in 1981?
Give a very brief answer. 1.46. What is the ratio of the Savings(% of GNI) in Bahamas in 1977 to that in 1982?
Offer a very short reply. 1.6. What is the ratio of the Savings(% of GNI) of Mali in 1977 to that in 1982?
Keep it short and to the point. 2.51. What is the ratio of the Savings(% of GNI) of Morocco in 1977 to that in 1982?
Give a very brief answer. 0.77. What is the ratio of the Savings(% of GNI) of Saudi Arabia in 1977 to that in 1982?
Your answer should be very brief. 2.23. What is the ratio of the Savings(% of GNI) in Bahamas in 1977 to that in 1983?
Offer a terse response. 2.11. What is the ratio of the Savings(% of GNI) in Mali in 1977 to that in 1983?
Keep it short and to the point. 6.17. What is the ratio of the Savings(% of GNI) in Morocco in 1977 to that in 1983?
Give a very brief answer. 0.78. What is the ratio of the Savings(% of GNI) of Saudi Arabia in 1977 to that in 1983?
Ensure brevity in your answer.  4.99. What is the ratio of the Savings(% of GNI) in Bahamas in 1977 to that in 1984?
Offer a terse response. 6.58. What is the ratio of the Savings(% of GNI) of Mali in 1977 to that in 1984?
Offer a terse response. 11.57. What is the ratio of the Savings(% of GNI) in Morocco in 1977 to that in 1984?
Give a very brief answer. 0.74. What is the ratio of the Savings(% of GNI) of Saudi Arabia in 1977 to that in 1984?
Offer a terse response. 76.02. What is the ratio of the Savings(% of GNI) in Bahamas in 1977 to that in 1985?
Keep it short and to the point. 3.56. What is the ratio of the Savings(% of GNI) of Morocco in 1977 to that in 1985?
Make the answer very short. 0.73. What is the ratio of the Savings(% of GNI) in Bahamas in 1978 to that in 1980?
Your response must be concise. 1.59. What is the ratio of the Savings(% of GNI) of Mali in 1978 to that in 1980?
Offer a terse response. 0.7. What is the ratio of the Savings(% of GNI) of Morocco in 1978 to that in 1980?
Ensure brevity in your answer.  0.73. What is the ratio of the Savings(% of GNI) of Saudi Arabia in 1978 to that in 1980?
Provide a succinct answer. 0.88. What is the ratio of the Savings(% of GNI) of Bahamas in 1978 to that in 1981?
Give a very brief answer. 1.43. What is the ratio of the Savings(% of GNI) of Mali in 1978 to that in 1981?
Ensure brevity in your answer.  0.88. What is the ratio of the Savings(% of GNI) of Morocco in 1978 to that in 1981?
Your response must be concise. 0.82. What is the ratio of the Savings(% of GNI) of Saudi Arabia in 1978 to that in 1981?
Your answer should be very brief. 0.87. What is the ratio of the Savings(% of GNI) in Bahamas in 1978 to that in 1982?
Offer a very short reply. 1.5. What is the ratio of the Savings(% of GNI) in Mali in 1978 to that in 1982?
Your answer should be very brief. 0.77. What is the ratio of the Savings(% of GNI) of Morocco in 1978 to that in 1982?
Your answer should be very brief. 0.77. What is the ratio of the Savings(% of GNI) of Saudi Arabia in 1978 to that in 1982?
Your response must be concise. 1.33. What is the ratio of the Savings(% of GNI) in Bahamas in 1978 to that in 1983?
Your response must be concise. 1.97. What is the ratio of the Savings(% of GNI) in Mali in 1978 to that in 1983?
Give a very brief answer. 1.88. What is the ratio of the Savings(% of GNI) in Morocco in 1978 to that in 1983?
Ensure brevity in your answer.  0.79. What is the ratio of the Savings(% of GNI) of Saudi Arabia in 1978 to that in 1983?
Your answer should be very brief. 2.97. What is the ratio of the Savings(% of GNI) in Bahamas in 1978 to that in 1984?
Provide a succinct answer. 6.16. What is the ratio of the Savings(% of GNI) in Mali in 1978 to that in 1984?
Give a very brief answer. 3.53. What is the ratio of the Savings(% of GNI) of Morocco in 1978 to that in 1984?
Keep it short and to the point. 0.75. What is the ratio of the Savings(% of GNI) in Saudi Arabia in 1978 to that in 1984?
Keep it short and to the point. 45.32. What is the ratio of the Savings(% of GNI) in Bahamas in 1978 to that in 1985?
Your response must be concise. 3.34. What is the ratio of the Savings(% of GNI) of Morocco in 1978 to that in 1985?
Your answer should be compact. 0.74. What is the ratio of the Savings(% of GNI) in Bahamas in 1980 to that in 1981?
Keep it short and to the point. 0.9. What is the ratio of the Savings(% of GNI) of Mali in 1980 to that in 1981?
Your response must be concise. 1.26. What is the ratio of the Savings(% of GNI) of Morocco in 1980 to that in 1981?
Offer a terse response. 1.12. What is the ratio of the Savings(% of GNI) of Saudi Arabia in 1980 to that in 1981?
Your answer should be compact. 0.99. What is the ratio of the Savings(% of GNI) of Bahamas in 1980 to that in 1982?
Make the answer very short. 0.94. What is the ratio of the Savings(% of GNI) in Mali in 1980 to that in 1982?
Keep it short and to the point. 1.1. What is the ratio of the Savings(% of GNI) in Morocco in 1980 to that in 1982?
Give a very brief answer. 1.07. What is the ratio of the Savings(% of GNI) in Saudi Arabia in 1980 to that in 1982?
Offer a very short reply. 1.51. What is the ratio of the Savings(% of GNI) of Bahamas in 1980 to that in 1983?
Make the answer very short. 1.24. What is the ratio of the Savings(% of GNI) of Mali in 1980 to that in 1983?
Offer a terse response. 2.7. What is the ratio of the Savings(% of GNI) in Morocco in 1980 to that in 1983?
Make the answer very short. 1.09. What is the ratio of the Savings(% of GNI) of Saudi Arabia in 1980 to that in 1983?
Offer a terse response. 3.37. What is the ratio of the Savings(% of GNI) of Bahamas in 1980 to that in 1984?
Provide a succinct answer. 3.88. What is the ratio of the Savings(% of GNI) of Mali in 1980 to that in 1984?
Your answer should be compact. 5.06. What is the ratio of the Savings(% of GNI) of Morocco in 1980 to that in 1984?
Your response must be concise. 1.03. What is the ratio of the Savings(% of GNI) of Saudi Arabia in 1980 to that in 1984?
Make the answer very short. 51.46. What is the ratio of the Savings(% of GNI) of Bahamas in 1980 to that in 1985?
Your answer should be very brief. 2.1. What is the ratio of the Savings(% of GNI) of Morocco in 1980 to that in 1985?
Provide a succinct answer. 1.02. What is the ratio of the Savings(% of GNI) of Bahamas in 1981 to that in 1982?
Your answer should be compact. 1.05. What is the ratio of the Savings(% of GNI) of Mali in 1981 to that in 1982?
Ensure brevity in your answer.  0.87. What is the ratio of the Savings(% of GNI) in Morocco in 1981 to that in 1982?
Provide a short and direct response. 0.95. What is the ratio of the Savings(% of GNI) in Saudi Arabia in 1981 to that in 1982?
Provide a short and direct response. 1.53. What is the ratio of the Savings(% of GNI) of Bahamas in 1981 to that in 1983?
Your answer should be very brief. 1.38. What is the ratio of the Savings(% of GNI) of Mali in 1981 to that in 1983?
Offer a terse response. 2.14. What is the ratio of the Savings(% of GNI) in Morocco in 1981 to that in 1983?
Make the answer very short. 0.97. What is the ratio of the Savings(% of GNI) of Saudi Arabia in 1981 to that in 1983?
Your answer should be very brief. 3.43. What is the ratio of the Savings(% of GNI) of Bahamas in 1981 to that in 1984?
Keep it short and to the point. 4.3. What is the ratio of the Savings(% of GNI) in Mali in 1981 to that in 1984?
Your response must be concise. 4.02. What is the ratio of the Savings(% of GNI) in Morocco in 1981 to that in 1984?
Give a very brief answer. 0.92. What is the ratio of the Savings(% of GNI) of Saudi Arabia in 1981 to that in 1984?
Offer a terse response. 52.24. What is the ratio of the Savings(% of GNI) of Bahamas in 1981 to that in 1985?
Your answer should be compact. 2.33. What is the ratio of the Savings(% of GNI) in Morocco in 1981 to that in 1985?
Provide a succinct answer. 0.9. What is the ratio of the Savings(% of GNI) in Bahamas in 1982 to that in 1983?
Offer a very short reply. 1.32. What is the ratio of the Savings(% of GNI) in Mali in 1982 to that in 1983?
Make the answer very short. 2.45. What is the ratio of the Savings(% of GNI) in Morocco in 1982 to that in 1983?
Ensure brevity in your answer.  1.02. What is the ratio of the Savings(% of GNI) in Saudi Arabia in 1982 to that in 1983?
Your answer should be compact. 2.24. What is the ratio of the Savings(% of GNI) of Bahamas in 1982 to that in 1984?
Provide a short and direct response. 4.11. What is the ratio of the Savings(% of GNI) in Mali in 1982 to that in 1984?
Give a very brief answer. 4.6. What is the ratio of the Savings(% of GNI) in Morocco in 1982 to that in 1984?
Offer a very short reply. 0.97. What is the ratio of the Savings(% of GNI) in Saudi Arabia in 1982 to that in 1984?
Give a very brief answer. 34.09. What is the ratio of the Savings(% of GNI) of Bahamas in 1982 to that in 1985?
Your response must be concise. 2.23. What is the ratio of the Savings(% of GNI) of Morocco in 1982 to that in 1985?
Make the answer very short. 0.95. What is the ratio of the Savings(% of GNI) in Bahamas in 1983 to that in 1984?
Your response must be concise. 3.12. What is the ratio of the Savings(% of GNI) of Mali in 1983 to that in 1984?
Ensure brevity in your answer.  1.88. What is the ratio of the Savings(% of GNI) in Morocco in 1983 to that in 1984?
Give a very brief answer. 0.95. What is the ratio of the Savings(% of GNI) in Saudi Arabia in 1983 to that in 1984?
Offer a terse response. 15.25. What is the ratio of the Savings(% of GNI) of Bahamas in 1983 to that in 1985?
Provide a succinct answer. 1.69. What is the ratio of the Savings(% of GNI) in Morocco in 1983 to that in 1985?
Make the answer very short. 0.93. What is the ratio of the Savings(% of GNI) of Bahamas in 1984 to that in 1985?
Offer a terse response. 0.54. What is the difference between the highest and the second highest Savings(% of GNI) in Bahamas?
Your response must be concise. 3.09. What is the difference between the highest and the second highest Savings(% of GNI) of Mali?
Provide a short and direct response. 8.96. What is the difference between the highest and the second highest Savings(% of GNI) in Morocco?
Your answer should be very brief. 0.36. What is the difference between the highest and the second highest Savings(% of GNI) in Saudi Arabia?
Make the answer very short. 7.32. What is the difference between the highest and the lowest Savings(% of GNI) in Bahamas?
Offer a terse response. 41.04. What is the difference between the highest and the lowest Savings(% of GNI) in Mali?
Your answer should be compact. 15.94. What is the difference between the highest and the lowest Savings(% of GNI) in Morocco?
Your answer should be very brief. 6.3. What is the difference between the highest and the lowest Savings(% of GNI) in Saudi Arabia?
Keep it short and to the point. 23.39. 